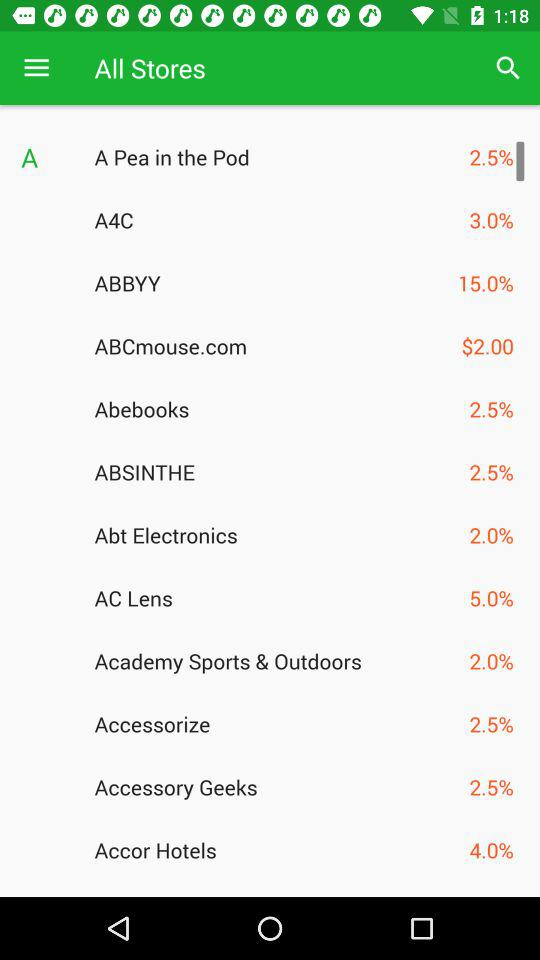What is the amount mentioned for "ABCmouse.com"? The amount mentioned for "ABCmouse.com" is $2.00. 